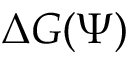<formula> <loc_0><loc_0><loc_500><loc_500>\Delta G ( \Psi )</formula> 